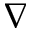Convert formula to latex. <formula><loc_0><loc_0><loc_500><loc_500>\nabla</formula> 